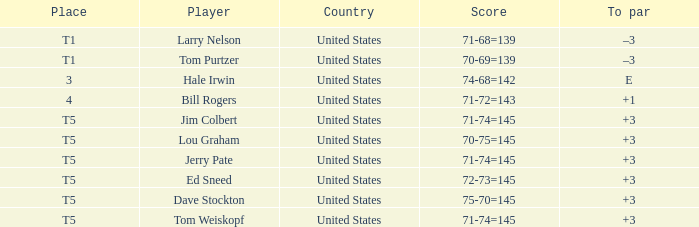Who is the player with a 70-75=145 score? Lou Graham. 